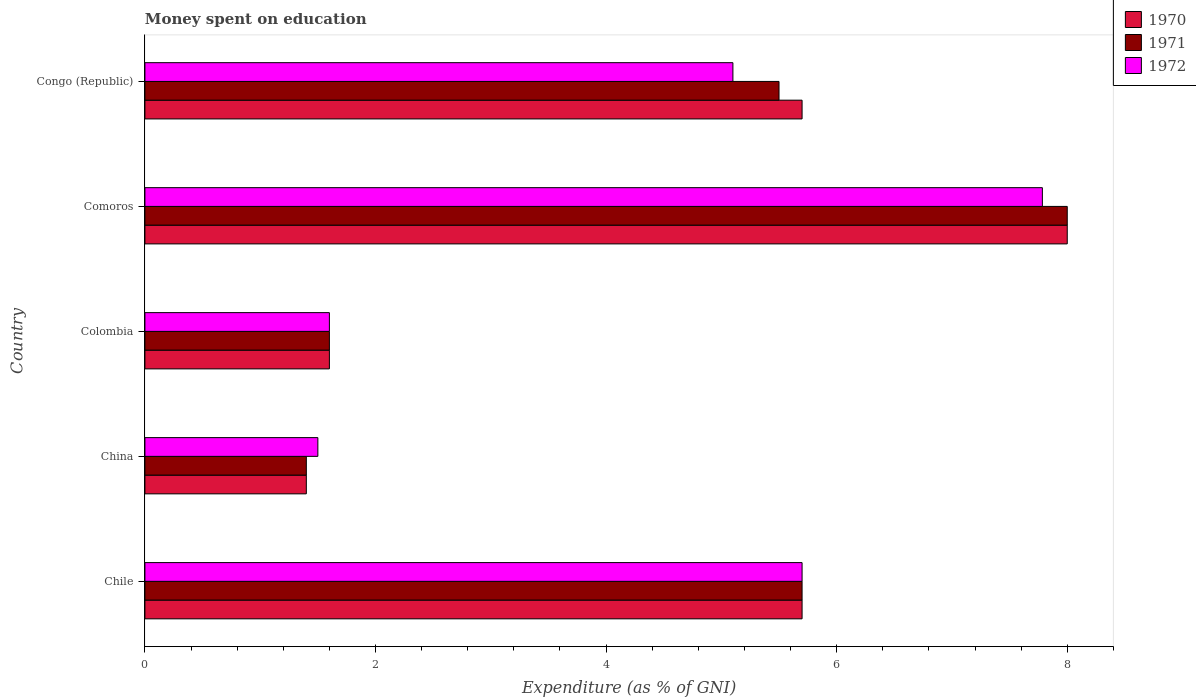How many different coloured bars are there?
Make the answer very short. 3. Are the number of bars on each tick of the Y-axis equal?
Provide a short and direct response. Yes. How many bars are there on the 5th tick from the bottom?
Your answer should be very brief. 3. What is the label of the 1st group of bars from the top?
Ensure brevity in your answer.  Congo (Republic). In how many cases, is the number of bars for a given country not equal to the number of legend labels?
Your answer should be compact. 0. Across all countries, what is the maximum amount of money spent on education in 1972?
Give a very brief answer. 7.78. Across all countries, what is the minimum amount of money spent on education in 1970?
Offer a very short reply. 1.4. In which country was the amount of money spent on education in 1971 maximum?
Provide a succinct answer. Comoros. In which country was the amount of money spent on education in 1971 minimum?
Make the answer very short. China. What is the total amount of money spent on education in 1972 in the graph?
Your response must be concise. 21.68. What is the difference between the amount of money spent on education in 1972 in Congo (Republic) and the amount of money spent on education in 1970 in Colombia?
Keep it short and to the point. 3.5. What is the average amount of money spent on education in 1970 per country?
Provide a succinct answer. 4.48. What is the difference between the amount of money spent on education in 1971 and amount of money spent on education in 1970 in Comoros?
Provide a short and direct response. 0. What is the ratio of the amount of money spent on education in 1971 in Comoros to that in Congo (Republic)?
Offer a terse response. 1.45. What is the difference between the highest and the second highest amount of money spent on education in 1972?
Your answer should be compact. 2.08. What is the difference between the highest and the lowest amount of money spent on education in 1971?
Your answer should be very brief. 6.6. In how many countries, is the amount of money spent on education in 1971 greater than the average amount of money spent on education in 1971 taken over all countries?
Provide a short and direct response. 3. What does the 2nd bar from the top in Colombia represents?
Offer a terse response. 1971. Are all the bars in the graph horizontal?
Give a very brief answer. Yes. How many countries are there in the graph?
Ensure brevity in your answer.  5. Where does the legend appear in the graph?
Your answer should be compact. Top right. What is the title of the graph?
Provide a short and direct response. Money spent on education. Does "1967" appear as one of the legend labels in the graph?
Provide a short and direct response. No. What is the label or title of the X-axis?
Your answer should be compact. Expenditure (as % of GNI). What is the label or title of the Y-axis?
Give a very brief answer. Country. What is the Expenditure (as % of GNI) of 1970 in China?
Offer a terse response. 1.4. What is the Expenditure (as % of GNI) of 1972 in China?
Ensure brevity in your answer.  1.5. What is the Expenditure (as % of GNI) of 1970 in Colombia?
Your response must be concise. 1.6. What is the Expenditure (as % of GNI) of 1971 in Colombia?
Offer a terse response. 1.6. What is the Expenditure (as % of GNI) in 1970 in Comoros?
Provide a succinct answer. 8. What is the Expenditure (as % of GNI) in 1971 in Comoros?
Offer a very short reply. 8. What is the Expenditure (as % of GNI) of 1972 in Comoros?
Your answer should be compact. 7.78. What is the Expenditure (as % of GNI) of 1970 in Congo (Republic)?
Offer a terse response. 5.7. What is the Expenditure (as % of GNI) of 1972 in Congo (Republic)?
Keep it short and to the point. 5.1. Across all countries, what is the maximum Expenditure (as % of GNI) in 1972?
Make the answer very short. 7.78. Across all countries, what is the minimum Expenditure (as % of GNI) of 1971?
Provide a succinct answer. 1.4. What is the total Expenditure (as % of GNI) of 1970 in the graph?
Your answer should be very brief. 22.4. What is the total Expenditure (as % of GNI) in 1971 in the graph?
Give a very brief answer. 22.2. What is the total Expenditure (as % of GNI) in 1972 in the graph?
Offer a terse response. 21.68. What is the difference between the Expenditure (as % of GNI) in 1971 in Chile and that in China?
Give a very brief answer. 4.3. What is the difference between the Expenditure (as % of GNI) of 1971 in Chile and that in Colombia?
Offer a terse response. 4.1. What is the difference between the Expenditure (as % of GNI) of 1972 in Chile and that in Comoros?
Offer a very short reply. -2.08. What is the difference between the Expenditure (as % of GNI) in 1972 in Chile and that in Congo (Republic)?
Offer a terse response. 0.6. What is the difference between the Expenditure (as % of GNI) in 1972 in China and that in Comoros?
Provide a succinct answer. -6.28. What is the difference between the Expenditure (as % of GNI) in 1970 in China and that in Congo (Republic)?
Give a very brief answer. -4.3. What is the difference between the Expenditure (as % of GNI) of 1972 in China and that in Congo (Republic)?
Provide a short and direct response. -3.6. What is the difference between the Expenditure (as % of GNI) of 1970 in Colombia and that in Comoros?
Give a very brief answer. -6.4. What is the difference between the Expenditure (as % of GNI) in 1972 in Colombia and that in Comoros?
Give a very brief answer. -6.18. What is the difference between the Expenditure (as % of GNI) of 1970 in Colombia and that in Congo (Republic)?
Your answer should be compact. -4.1. What is the difference between the Expenditure (as % of GNI) in 1970 in Comoros and that in Congo (Republic)?
Make the answer very short. 2.3. What is the difference between the Expenditure (as % of GNI) of 1971 in Comoros and that in Congo (Republic)?
Keep it short and to the point. 2.5. What is the difference between the Expenditure (as % of GNI) of 1972 in Comoros and that in Congo (Republic)?
Provide a short and direct response. 2.68. What is the difference between the Expenditure (as % of GNI) of 1970 in Chile and the Expenditure (as % of GNI) of 1971 in China?
Your answer should be compact. 4.3. What is the difference between the Expenditure (as % of GNI) of 1970 in Chile and the Expenditure (as % of GNI) of 1972 in China?
Provide a succinct answer. 4.2. What is the difference between the Expenditure (as % of GNI) of 1970 in Chile and the Expenditure (as % of GNI) of 1971 in Colombia?
Your answer should be very brief. 4.1. What is the difference between the Expenditure (as % of GNI) in 1970 in Chile and the Expenditure (as % of GNI) in 1972 in Colombia?
Your answer should be compact. 4.1. What is the difference between the Expenditure (as % of GNI) of 1971 in Chile and the Expenditure (as % of GNI) of 1972 in Colombia?
Offer a terse response. 4.1. What is the difference between the Expenditure (as % of GNI) of 1970 in Chile and the Expenditure (as % of GNI) of 1972 in Comoros?
Keep it short and to the point. -2.08. What is the difference between the Expenditure (as % of GNI) of 1971 in Chile and the Expenditure (as % of GNI) of 1972 in Comoros?
Your answer should be compact. -2.08. What is the difference between the Expenditure (as % of GNI) in 1971 in Chile and the Expenditure (as % of GNI) in 1972 in Congo (Republic)?
Provide a succinct answer. 0.6. What is the difference between the Expenditure (as % of GNI) of 1970 in China and the Expenditure (as % of GNI) of 1971 in Colombia?
Ensure brevity in your answer.  -0.2. What is the difference between the Expenditure (as % of GNI) in 1970 in China and the Expenditure (as % of GNI) in 1972 in Colombia?
Keep it short and to the point. -0.2. What is the difference between the Expenditure (as % of GNI) in 1970 in China and the Expenditure (as % of GNI) in 1972 in Comoros?
Your response must be concise. -6.38. What is the difference between the Expenditure (as % of GNI) in 1971 in China and the Expenditure (as % of GNI) in 1972 in Comoros?
Your response must be concise. -6.38. What is the difference between the Expenditure (as % of GNI) in 1970 in China and the Expenditure (as % of GNI) in 1971 in Congo (Republic)?
Your answer should be very brief. -4.1. What is the difference between the Expenditure (as % of GNI) of 1970 in Colombia and the Expenditure (as % of GNI) of 1971 in Comoros?
Provide a succinct answer. -6.4. What is the difference between the Expenditure (as % of GNI) in 1970 in Colombia and the Expenditure (as % of GNI) in 1972 in Comoros?
Your response must be concise. -6.18. What is the difference between the Expenditure (as % of GNI) of 1971 in Colombia and the Expenditure (as % of GNI) of 1972 in Comoros?
Your answer should be very brief. -6.18. What is the difference between the Expenditure (as % of GNI) of 1971 in Colombia and the Expenditure (as % of GNI) of 1972 in Congo (Republic)?
Ensure brevity in your answer.  -3.5. What is the difference between the Expenditure (as % of GNI) of 1970 in Comoros and the Expenditure (as % of GNI) of 1972 in Congo (Republic)?
Make the answer very short. 2.9. What is the difference between the Expenditure (as % of GNI) of 1971 in Comoros and the Expenditure (as % of GNI) of 1972 in Congo (Republic)?
Provide a succinct answer. 2.9. What is the average Expenditure (as % of GNI) of 1970 per country?
Provide a succinct answer. 4.48. What is the average Expenditure (as % of GNI) in 1971 per country?
Provide a short and direct response. 4.44. What is the average Expenditure (as % of GNI) of 1972 per country?
Keep it short and to the point. 4.34. What is the difference between the Expenditure (as % of GNI) of 1970 and Expenditure (as % of GNI) of 1971 in Chile?
Provide a succinct answer. 0. What is the difference between the Expenditure (as % of GNI) in 1971 and Expenditure (as % of GNI) in 1972 in Chile?
Your answer should be very brief. 0. What is the difference between the Expenditure (as % of GNI) of 1970 and Expenditure (as % of GNI) of 1972 in China?
Ensure brevity in your answer.  -0.1. What is the difference between the Expenditure (as % of GNI) in 1970 and Expenditure (as % of GNI) in 1971 in Colombia?
Your response must be concise. 0. What is the difference between the Expenditure (as % of GNI) in 1971 and Expenditure (as % of GNI) in 1972 in Colombia?
Ensure brevity in your answer.  0. What is the difference between the Expenditure (as % of GNI) in 1970 and Expenditure (as % of GNI) in 1971 in Comoros?
Make the answer very short. 0. What is the difference between the Expenditure (as % of GNI) in 1970 and Expenditure (as % of GNI) in 1972 in Comoros?
Keep it short and to the point. 0.22. What is the difference between the Expenditure (as % of GNI) in 1971 and Expenditure (as % of GNI) in 1972 in Comoros?
Make the answer very short. 0.22. What is the ratio of the Expenditure (as % of GNI) in 1970 in Chile to that in China?
Ensure brevity in your answer.  4.07. What is the ratio of the Expenditure (as % of GNI) of 1971 in Chile to that in China?
Offer a very short reply. 4.07. What is the ratio of the Expenditure (as % of GNI) of 1972 in Chile to that in China?
Offer a terse response. 3.8. What is the ratio of the Expenditure (as % of GNI) of 1970 in Chile to that in Colombia?
Give a very brief answer. 3.56. What is the ratio of the Expenditure (as % of GNI) in 1971 in Chile to that in Colombia?
Ensure brevity in your answer.  3.56. What is the ratio of the Expenditure (as % of GNI) of 1972 in Chile to that in Colombia?
Your answer should be compact. 3.56. What is the ratio of the Expenditure (as % of GNI) of 1970 in Chile to that in Comoros?
Give a very brief answer. 0.71. What is the ratio of the Expenditure (as % of GNI) in 1971 in Chile to that in Comoros?
Ensure brevity in your answer.  0.71. What is the ratio of the Expenditure (as % of GNI) in 1972 in Chile to that in Comoros?
Your answer should be very brief. 0.73. What is the ratio of the Expenditure (as % of GNI) in 1970 in Chile to that in Congo (Republic)?
Offer a very short reply. 1. What is the ratio of the Expenditure (as % of GNI) of 1971 in Chile to that in Congo (Republic)?
Ensure brevity in your answer.  1.04. What is the ratio of the Expenditure (as % of GNI) in 1972 in Chile to that in Congo (Republic)?
Your answer should be compact. 1.12. What is the ratio of the Expenditure (as % of GNI) of 1971 in China to that in Colombia?
Provide a succinct answer. 0.88. What is the ratio of the Expenditure (as % of GNI) in 1970 in China to that in Comoros?
Ensure brevity in your answer.  0.17. What is the ratio of the Expenditure (as % of GNI) of 1971 in China to that in Comoros?
Provide a succinct answer. 0.17. What is the ratio of the Expenditure (as % of GNI) of 1972 in China to that in Comoros?
Offer a very short reply. 0.19. What is the ratio of the Expenditure (as % of GNI) of 1970 in China to that in Congo (Republic)?
Give a very brief answer. 0.25. What is the ratio of the Expenditure (as % of GNI) in 1971 in China to that in Congo (Republic)?
Offer a terse response. 0.25. What is the ratio of the Expenditure (as % of GNI) of 1972 in China to that in Congo (Republic)?
Provide a succinct answer. 0.29. What is the ratio of the Expenditure (as % of GNI) in 1971 in Colombia to that in Comoros?
Provide a succinct answer. 0.2. What is the ratio of the Expenditure (as % of GNI) of 1972 in Colombia to that in Comoros?
Your answer should be very brief. 0.21. What is the ratio of the Expenditure (as % of GNI) in 1970 in Colombia to that in Congo (Republic)?
Your response must be concise. 0.28. What is the ratio of the Expenditure (as % of GNI) of 1971 in Colombia to that in Congo (Republic)?
Make the answer very short. 0.29. What is the ratio of the Expenditure (as % of GNI) in 1972 in Colombia to that in Congo (Republic)?
Ensure brevity in your answer.  0.31. What is the ratio of the Expenditure (as % of GNI) in 1970 in Comoros to that in Congo (Republic)?
Your response must be concise. 1.4. What is the ratio of the Expenditure (as % of GNI) in 1971 in Comoros to that in Congo (Republic)?
Offer a very short reply. 1.45. What is the ratio of the Expenditure (as % of GNI) in 1972 in Comoros to that in Congo (Republic)?
Provide a short and direct response. 1.53. What is the difference between the highest and the second highest Expenditure (as % of GNI) in 1972?
Offer a very short reply. 2.08. What is the difference between the highest and the lowest Expenditure (as % of GNI) of 1971?
Provide a short and direct response. 6.6. What is the difference between the highest and the lowest Expenditure (as % of GNI) of 1972?
Keep it short and to the point. 6.28. 